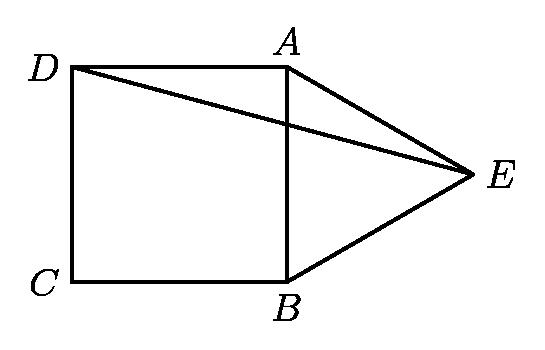How would the size of angle AED change if point E were moved closer to point D along the extension of line CD? If point E were moved closer to point D along the extension of line CD, angle AED would increase. This is because angle AED is the exterior angle for triangle ABE and is equal to the sum of the remote interior angles (which remain constant). Since the distance from E to the square affects the length of DE while AE remains constant, the angle AED opens wider as E approaches D. 